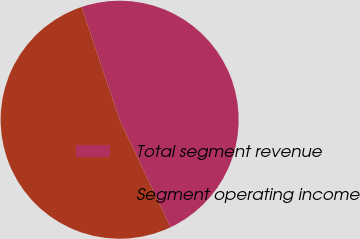Convert chart. <chart><loc_0><loc_0><loc_500><loc_500><pie_chart><fcel>Total segment revenue<fcel>Segment operating income<nl><fcel>48.15%<fcel>51.85%<nl></chart> 